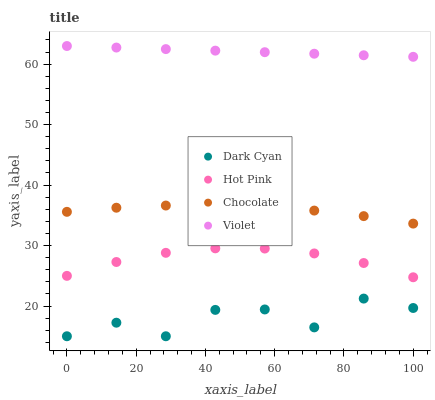Does Dark Cyan have the minimum area under the curve?
Answer yes or no. Yes. Does Violet have the maximum area under the curve?
Answer yes or no. Yes. Does Hot Pink have the minimum area under the curve?
Answer yes or no. No. Does Hot Pink have the maximum area under the curve?
Answer yes or no. No. Is Violet the smoothest?
Answer yes or no. Yes. Is Dark Cyan the roughest?
Answer yes or no. Yes. Is Hot Pink the smoothest?
Answer yes or no. No. Is Hot Pink the roughest?
Answer yes or no. No. Does Dark Cyan have the lowest value?
Answer yes or no. Yes. Does Hot Pink have the lowest value?
Answer yes or no. No. Does Violet have the highest value?
Answer yes or no. Yes. Does Hot Pink have the highest value?
Answer yes or no. No. Is Chocolate less than Violet?
Answer yes or no. Yes. Is Violet greater than Chocolate?
Answer yes or no. Yes. Does Chocolate intersect Violet?
Answer yes or no. No. 